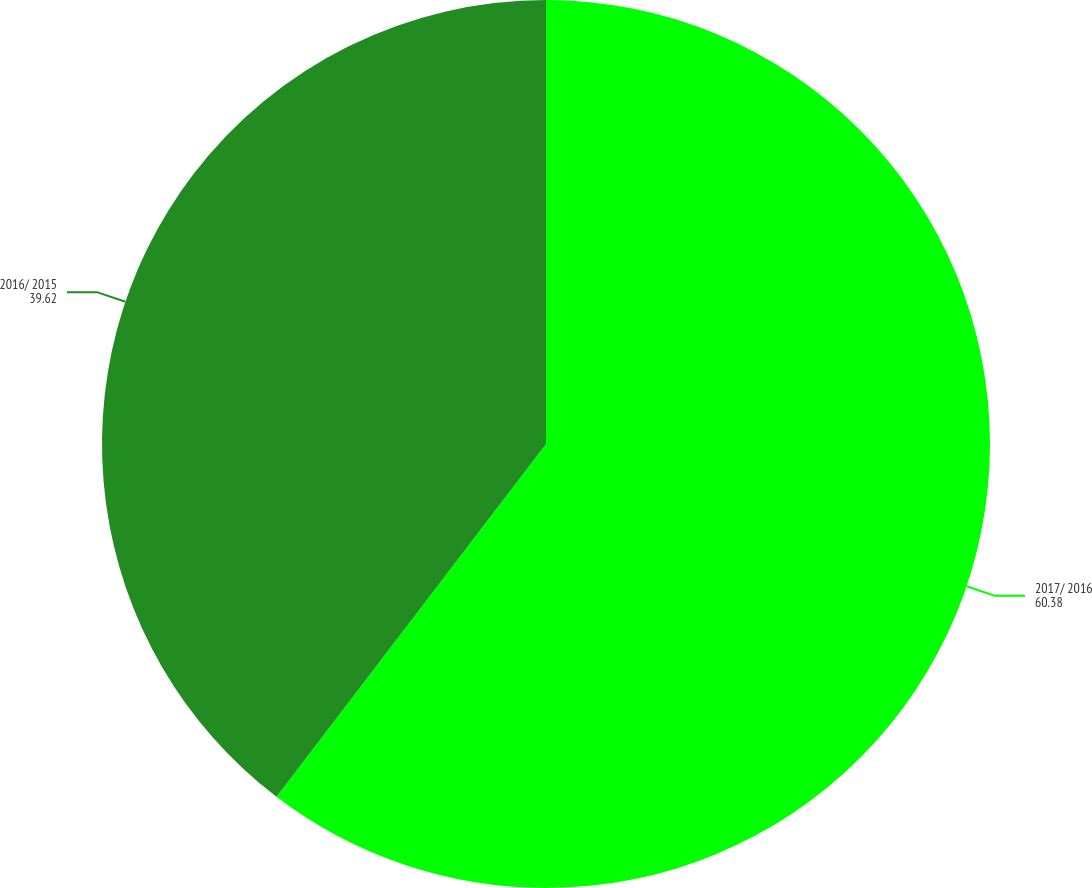Convert chart. <chart><loc_0><loc_0><loc_500><loc_500><pie_chart><fcel>2017/ 2016<fcel>2016/ 2015<nl><fcel>60.38%<fcel>39.62%<nl></chart> 